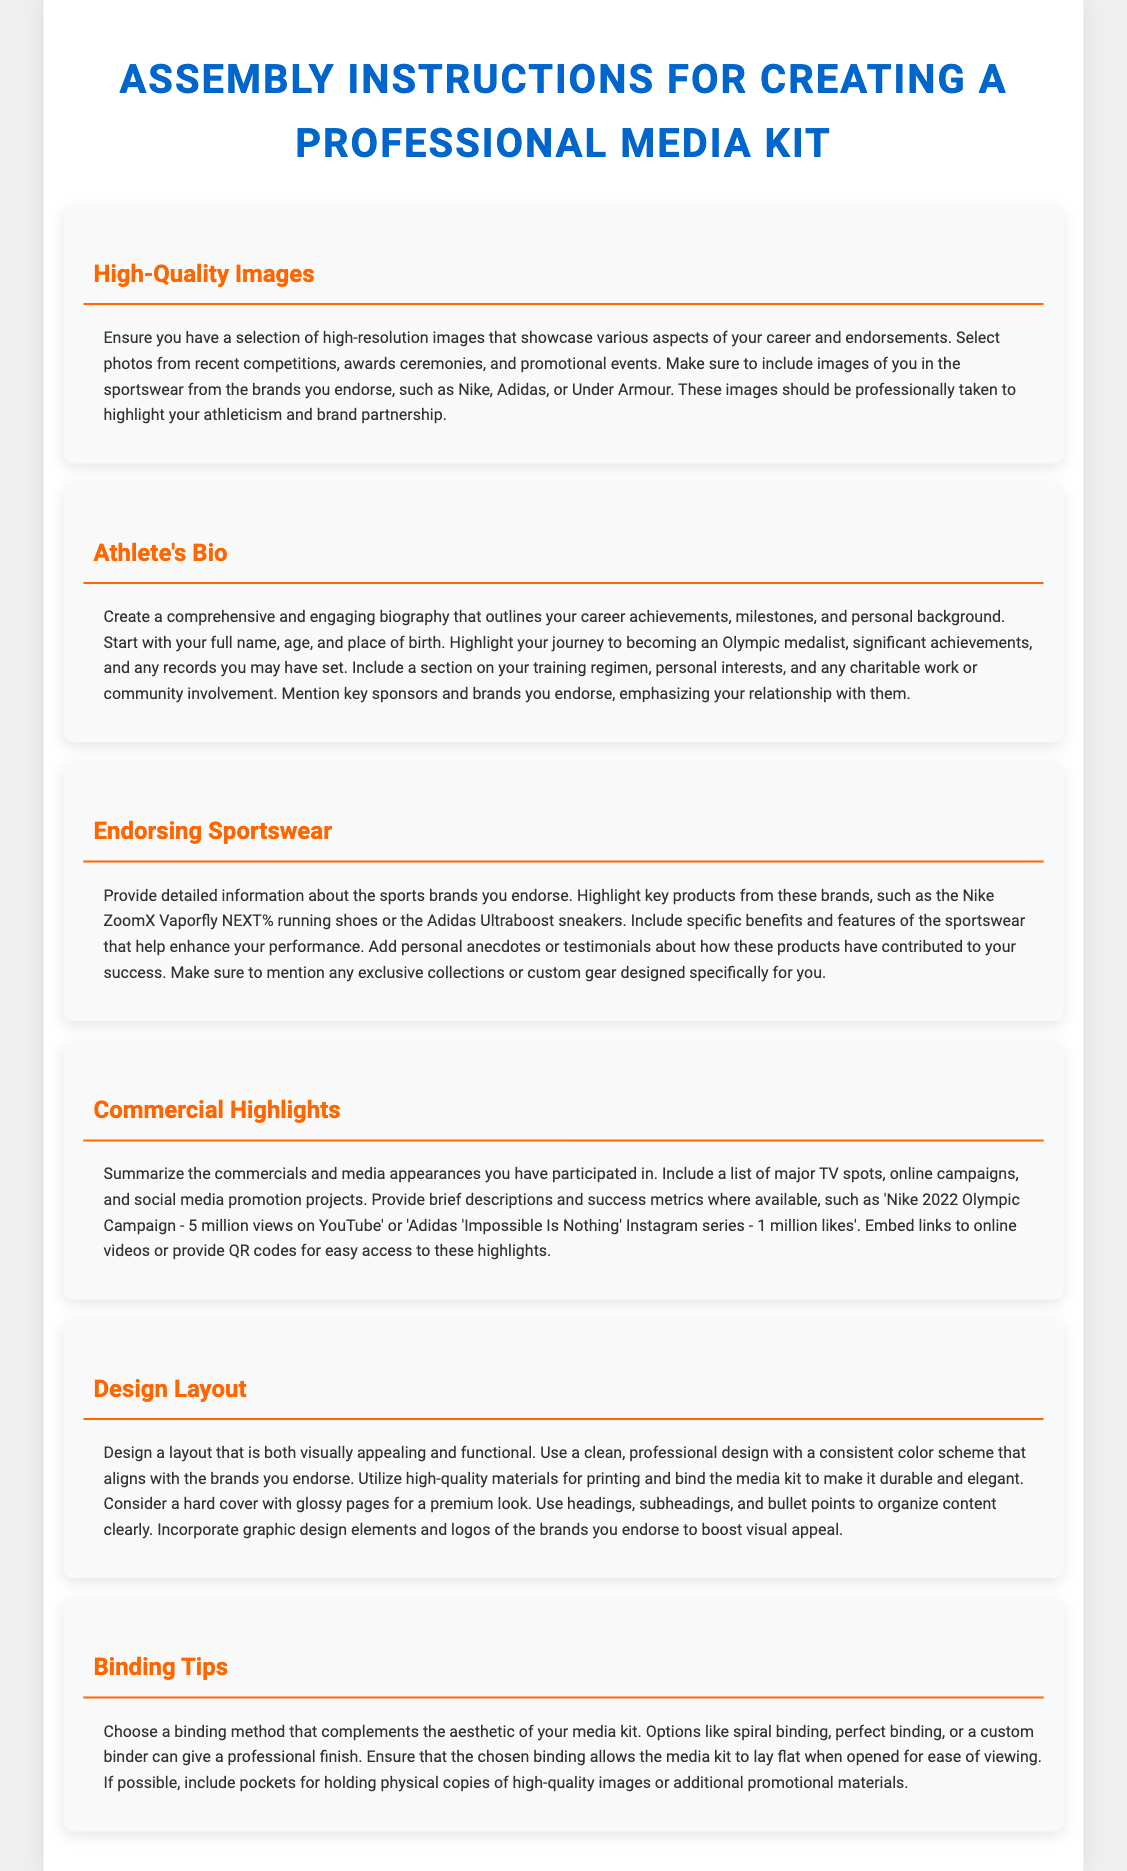What should the athlete's bio include? The athlete's bio should include career achievements, milestones, personal background, training regimen, personal interests, charitable work, and key sponsors.
Answer: Comprehensive and engaging biography What is recommended for high-quality images? High-quality images should be high-resolution, showcasing recent competitions, awards, promotional events, and images in endorsed sportswear.
Answer: High-resolution images Which brands are mentioned for endorsing sportswear? The brands mentioned for endorsing sportswear are Nike, Adidas, and Under Armour.
Answer: Nike, Adidas, Under Armour What binding options are suggested for the media kit? Suggested binding options include spiral binding, perfect binding, or a custom binder.
Answer: Spiral binding, perfect binding, custom binder How should the design layout be characterized? The design layout should be clean, professional, visually appealing, and consistent with the brands.
Answer: Clean and professional design What type of content is summarized in the Commercial Highlights section? The Commercial Highlights section summarizes commercials and media appearances the athlete has participated in.
Answer: Commercials and media appearances What should the design layout incorporate to boost visual appeal? The design layout should incorporate graphic design elements and logos of the brands endorsed.
Answer: Graphic design elements and logos How should the media kit be printed? The media kit should be printed using high-quality materials for durability and elegance.
Answer: High-quality materials for printing 